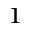Convert formula to latex. <formula><loc_0><loc_0><loc_500><loc_500>^ { 1 }</formula> 